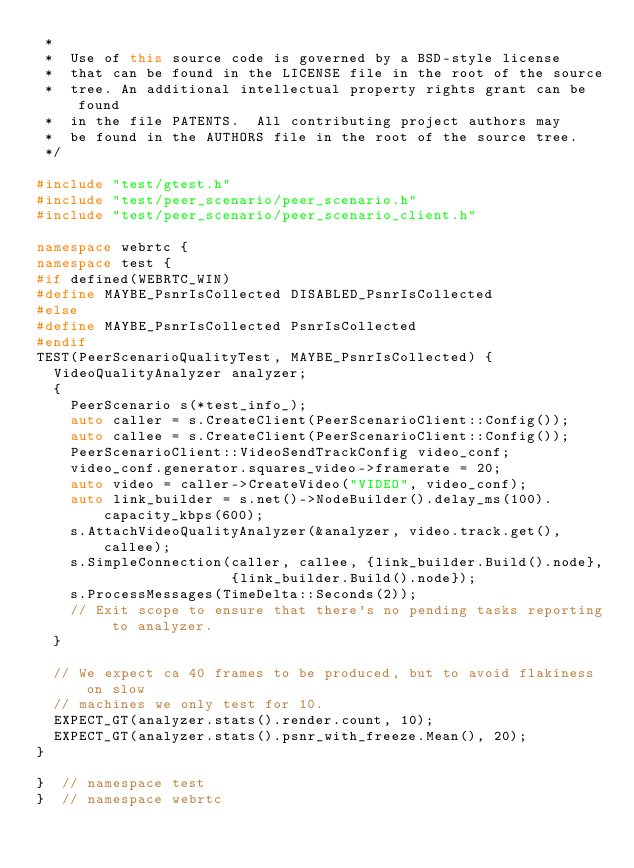<code> <loc_0><loc_0><loc_500><loc_500><_C++_> *
 *  Use of this source code is governed by a BSD-style license
 *  that can be found in the LICENSE file in the root of the source
 *  tree. An additional intellectual property rights grant can be found
 *  in the file PATENTS.  All contributing project authors may
 *  be found in the AUTHORS file in the root of the source tree.
 */

#include "test/gtest.h"
#include "test/peer_scenario/peer_scenario.h"
#include "test/peer_scenario/peer_scenario_client.h"

namespace webrtc {
namespace test {
#if defined(WEBRTC_WIN)
#define MAYBE_PsnrIsCollected DISABLED_PsnrIsCollected
#else
#define MAYBE_PsnrIsCollected PsnrIsCollected
#endif
TEST(PeerScenarioQualityTest, MAYBE_PsnrIsCollected) {
  VideoQualityAnalyzer analyzer;
  {
    PeerScenario s(*test_info_);
    auto caller = s.CreateClient(PeerScenarioClient::Config());
    auto callee = s.CreateClient(PeerScenarioClient::Config());
    PeerScenarioClient::VideoSendTrackConfig video_conf;
    video_conf.generator.squares_video->framerate = 20;
    auto video = caller->CreateVideo("VIDEO", video_conf);
    auto link_builder = s.net()->NodeBuilder().delay_ms(100).capacity_kbps(600);
    s.AttachVideoQualityAnalyzer(&analyzer, video.track.get(), callee);
    s.SimpleConnection(caller, callee, {link_builder.Build().node},
                       {link_builder.Build().node});
    s.ProcessMessages(TimeDelta::Seconds(2));
    // Exit scope to ensure that there's no pending tasks reporting to analyzer.
  }

  // We expect ca 40 frames to be produced, but to avoid flakiness on slow
  // machines we only test for 10.
  EXPECT_GT(analyzer.stats().render.count, 10);
  EXPECT_GT(analyzer.stats().psnr_with_freeze.Mean(), 20);
}

}  // namespace test
}  // namespace webrtc
</code> 